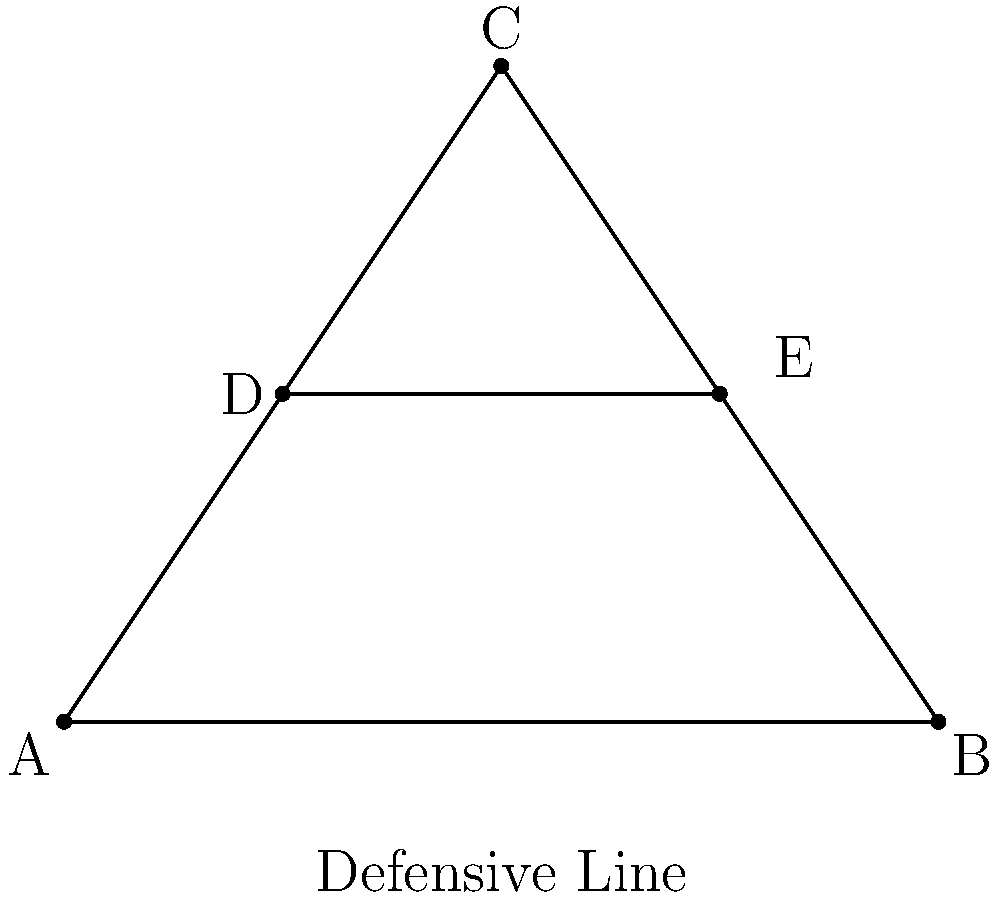In our defensive formation, we're using a triangular setup with three players at points A, B, and C. Two additional players are positioned at points D and E. If the length of AB is 8 meters and the height of the triangle (perpendicular distance from C to AB) is 6 meters, what is the length of DE in meters? Let's approach this step-by-step:

1) First, we need to recognize that DE is parallel to AB and is positioned halfway up the height of the triangle.

2) The triangle ABC is right-angled at the point where the height meets AB. Let's call this point M.

3) AM : MB = DM : ME (because D and E divide the sides of the triangle in the same ratio)

4) Since D and E are halfway up the height, DM = ME = 3 meters (half of the 6-meter height)

5) Now, we can set up a proportion:
   $\frac{DE}{AB} = \frac{DM}{CM} = \frac{3}{6} = \frac{1}{2}$

6) We know that AB = 8 meters, so:
   $\frac{DE}{8} = \frac{1}{2}$

7) Solving for DE:
   $DE = 8 \cdot \frac{1}{2} = 4$

Therefore, the length of DE is 4 meters.
Answer: 4 meters 